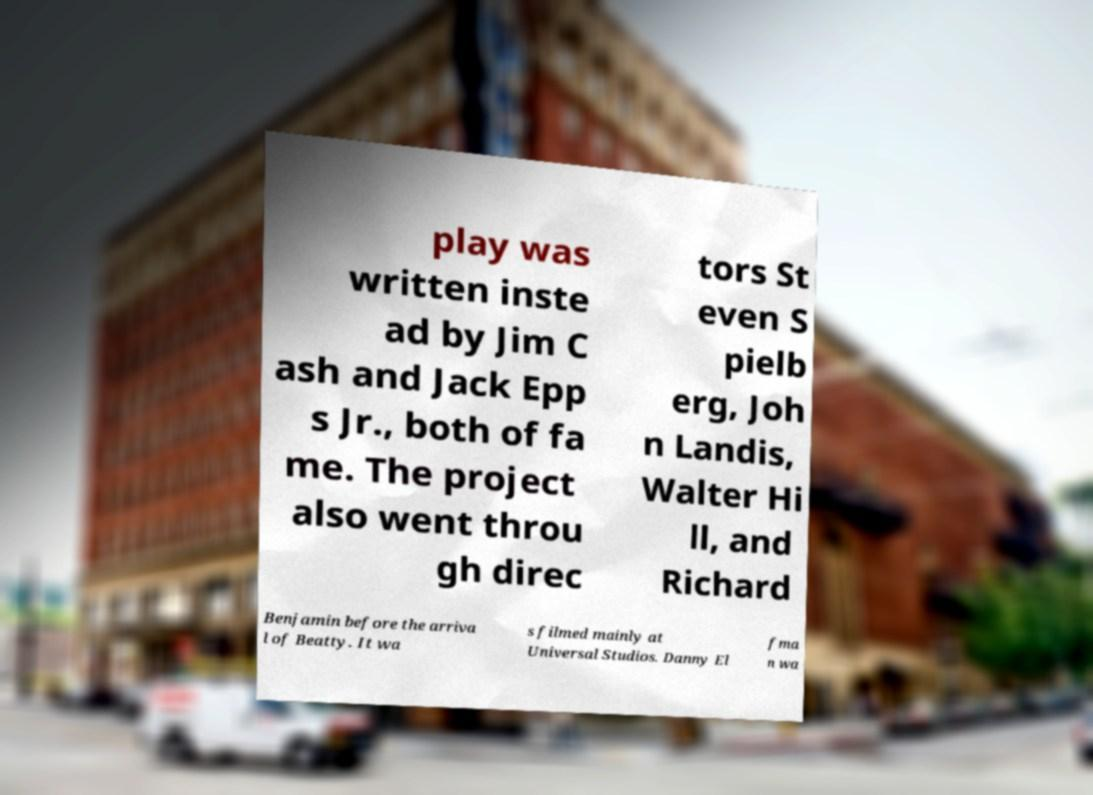Please identify and transcribe the text found in this image. play was written inste ad by Jim C ash and Jack Epp s Jr., both of fa me. The project also went throu gh direc tors St even S pielb erg, Joh n Landis, Walter Hi ll, and Richard Benjamin before the arriva l of Beatty. It wa s filmed mainly at Universal Studios. Danny El fma n wa 